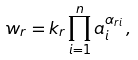Convert formula to latex. <formula><loc_0><loc_0><loc_500><loc_500>w _ { r } = k _ { r } \prod _ { i = 1 } ^ { n } a _ { i } ^ { \alpha _ { r i } } \, ,</formula> 